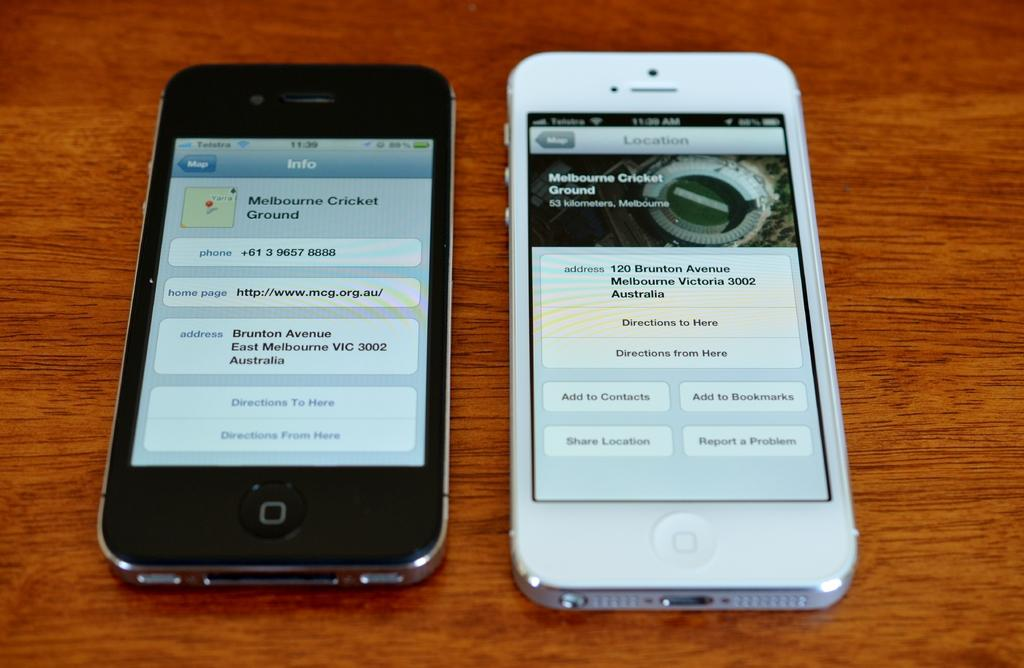What piece of furniture is present in the image? There is a table in the image. What objects are on the table? There are two mobile phones on the table. What type of ice is being served on the cart in the image? There is no ice or cart present in the image; it only features a table with two mobile phones. 